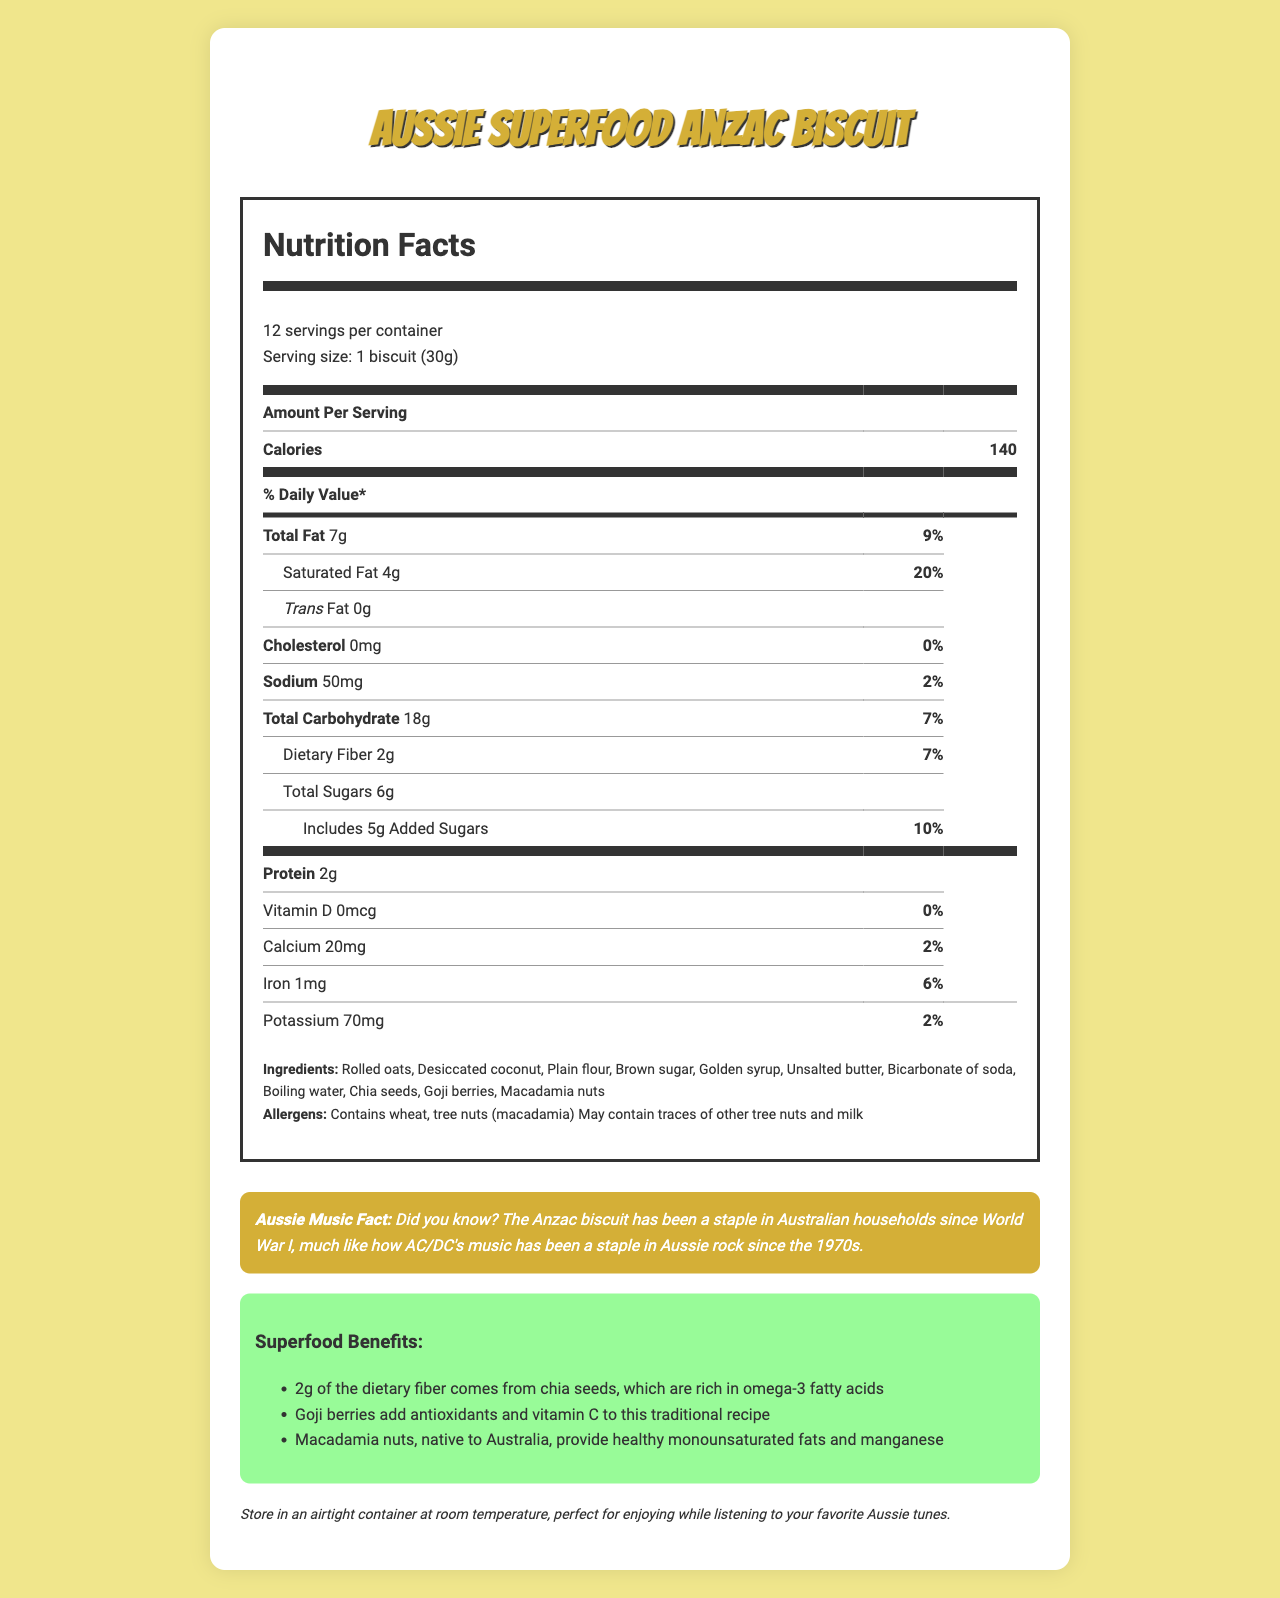how many servings are in the container? According to the document, there are 12 servings per container.
Answer: 12 what is the serving size of the Anzac biscuit? The serving size mentioned in the document is 1 biscuit (30g).
Answer: 1 biscuit (30g) how many calories are in one serving of the Anzac biscuit? The document states that one serving of the Anzac biscuit contains 140 calories.
Answer: 140 how much total fat is in one serving of the Anzac biscuit? The document indicates that one serving of the Anzac biscuit has 7g of total fat.
Answer: 7g what is the % Daily Value of saturated fat in one serving? The document shows that the % Daily Value of saturated fat in one serving is 20%.
Answer: 20% what does the document say about the cholesterol content? The document states that each serving contains 0mg of cholesterol, which is 0% of the Daily Value.
Answer: 0mg, 0% how much sodium is in one serving? According to the document, one serving contains 50mg of sodium.
Answer: 50mg which ingredient provides 2g of dietary fiber? The document mentions that 2g of dietary fiber comes from chia seeds.
Answer: Chia seeds what are the allergens listed in the document? The allergens listed in the document are wheat, tree nuts (macadamia) and may contain traces of other tree nuts and milk.
Answer: Contains wheat, tree nuts (macadamia); May contain traces of other tree nuts and milk what is the protein content per serving? The document states that each serving has 2g of protein.
Answer: 2g which superfood adds antioxidants and vitamin C to the Anzac biscuit? A. Chia seeds B. Goji berries C. Macadamia nuts The document mentions that goji berries add antioxidants and vitamin C to the Anzac biscuit.
Answer: B what benefit do macadamia nuts provide? A. Dietary fiber B. Healthy fats and manganese C. Antioxidants The document states that macadamia nuts provide healthy monounsaturated fats and manganese.
Answer: B what is the percentage of Daily Value for calcium per serving? The document indicates that the percentage of Daily Value for calcium per serving is 2%.
Answer: 2% does the document state that the Anzac biscuit contains any trans fat? The document shows that each serving contains 0g of trans fat.
Answer: No what is the main idea of this document? The document offers a detailed overview of the Anzac biscuit's nutritional content, lists ingredients and allergens, highlights the benefits of its superfood components, gives storage guidance, and includes a fun Australian music fact.
Answer: The document provides nutritional information for a traditional Anzac biscuit with added superfood ingredients, along with its storage instructions, allergens, and a fun fact about Australian music. what year did the Anzac biscuit become a staple in Australian households? The document mentions that the Anzac biscuit became a staple during World War I, but it doesn't specify the exact year.
Answer: Not enough information how much vitamin D is there per serving? According to the document, each serving contains 0mcg of vitamin D, which is 0% of the Daily Value.
Answer: 0mcg, 0% is there any golden syrup in the ingredient list? The document lists golden syrup as one of the ingredients.
Answer: Yes how many grams of added sugars are in one serving? The document states that there are 5g of added sugars in one serving.
Answer: 5g 